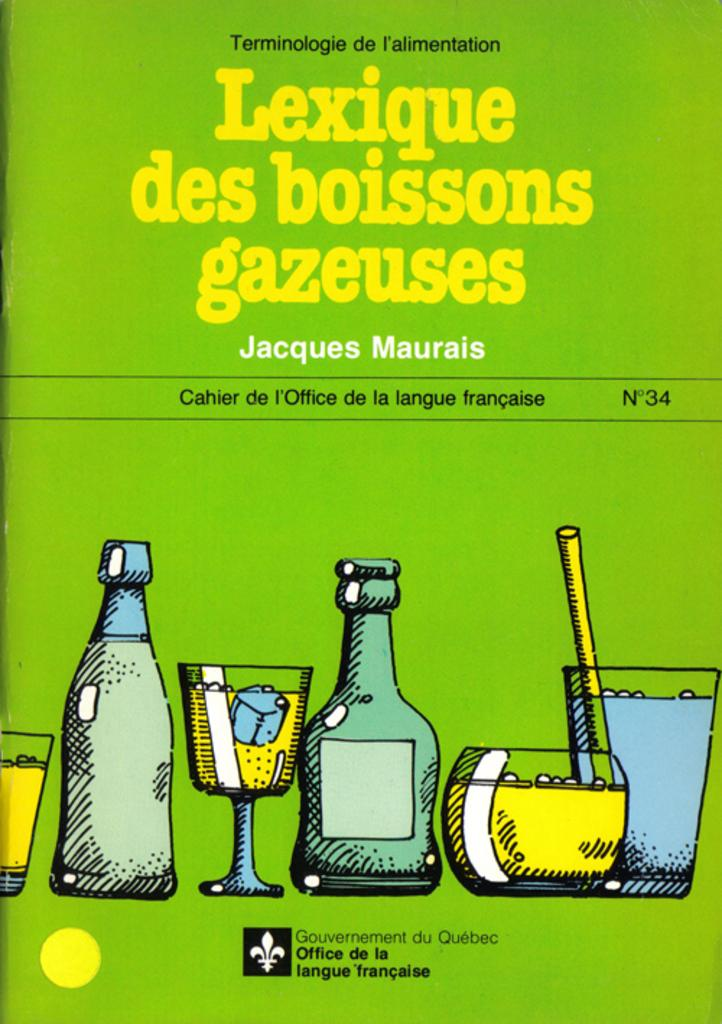<image>
Offer a succinct explanation of the picture presented. The Gouvernement du Quebec Office de la langue francaise is the organization responsible for this publication. 